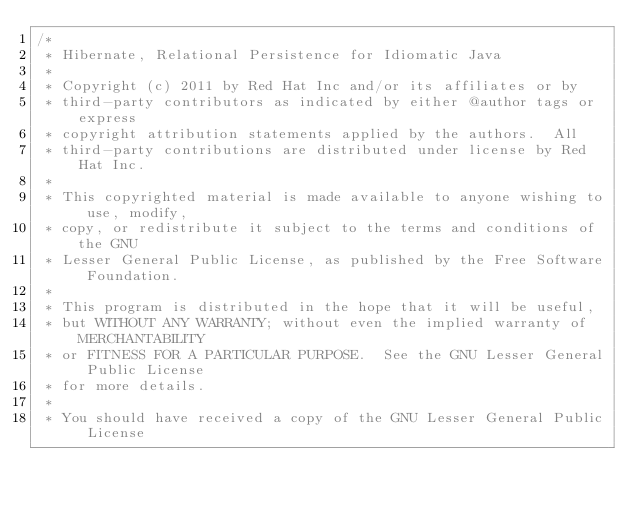Convert code to text. <code><loc_0><loc_0><loc_500><loc_500><_Java_>/*
 * Hibernate, Relational Persistence for Idiomatic Java
 *
 * Copyright (c) 2011 by Red Hat Inc and/or its affiliates or by
 * third-party contributors as indicated by either @author tags or express
 * copyright attribution statements applied by the authors.  All
 * third-party contributions are distributed under license by Red Hat Inc.
 *
 * This copyrighted material is made available to anyone wishing to use, modify,
 * copy, or redistribute it subject to the terms and conditions of the GNU
 * Lesser General Public License, as published by the Free Software Foundation.
 *
 * This program is distributed in the hope that it will be useful,
 * but WITHOUT ANY WARRANTY; without even the implied warranty of MERCHANTABILITY
 * or FITNESS FOR A PARTICULAR PURPOSE.  See the GNU Lesser General Public License
 * for more details.
 *
 * You should have received a copy of the GNU Lesser General Public License</code> 